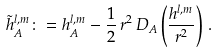Convert formula to latex. <formula><loc_0><loc_0><loc_500><loc_500>\tilde { h } _ { A } ^ { l , m } \colon = h _ { A } ^ { l , m } - \frac { 1 } { 2 } \, r ^ { 2 } \, D _ { A } \left ( \frac { h ^ { l , m } } { r ^ { 2 } } \right ) \, .</formula> 